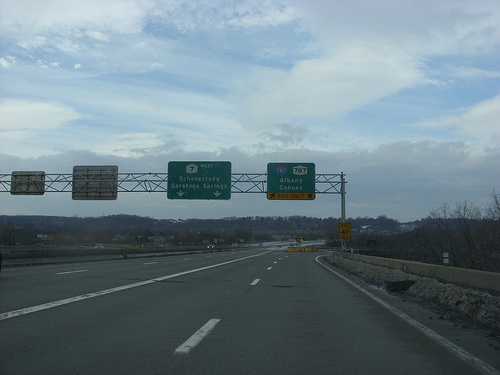Describe the objects in this image and their specific colors. I can see car in lightblue, black, purple, gray, and darkgray tones and car in gray, lightblue, purple, and black tones in this image. 